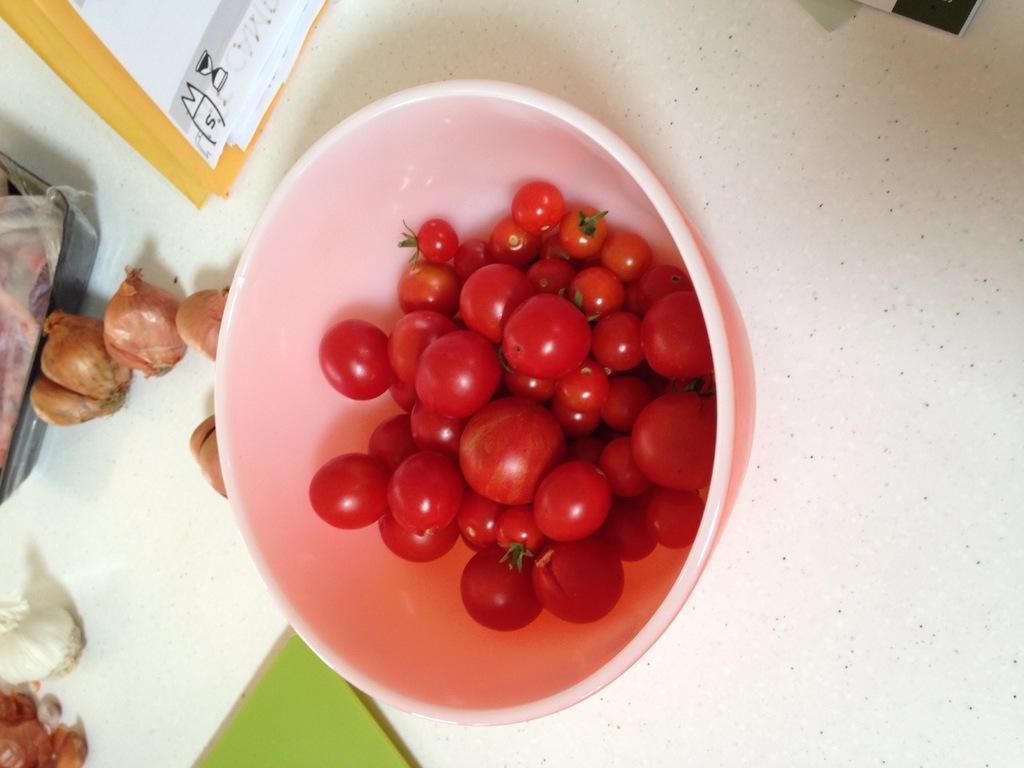Can you describe this image briefly? In this picture we can see a bowl with tomatoes on an object and on the object there are onions and other things. 